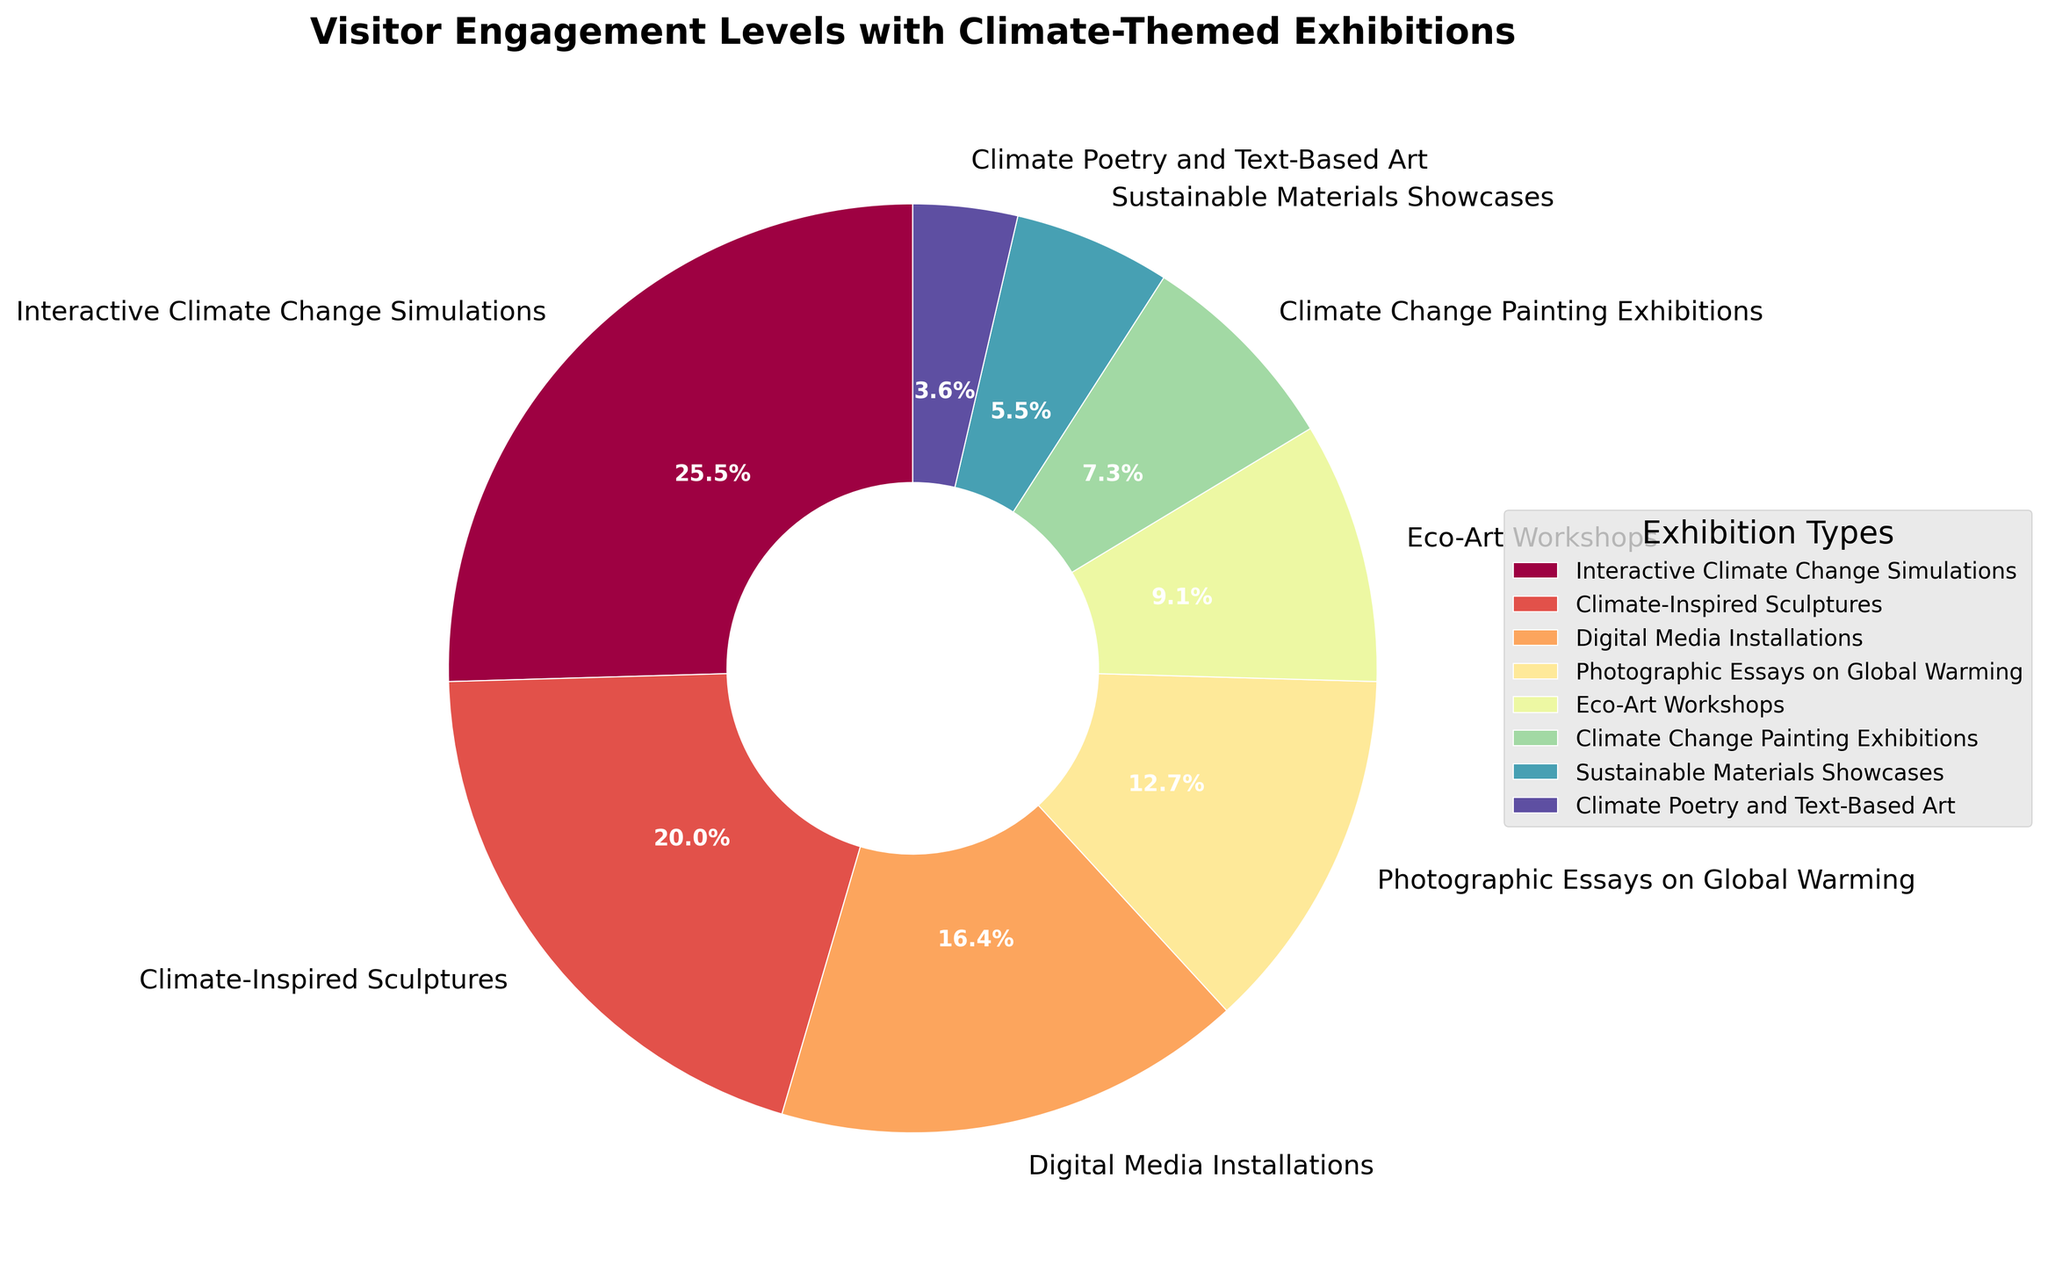Which climate-themed exhibition category has the highest visitor engagement? The figure shows "Interactive Climate Change Simulations" with the largest wedge in the pie chart, labeled 28%. This indicates it has the highest visitor engagement.
Answer: Interactive Climate Change Simulations How many percentage points greater is the engagement with Climate-Inspired Sculptures compared to Climate Change Painting Exhibitions? Climate-Inspired Sculptures engage 22% of visitors while Climate Change Painting Exhibitions engage 8%. The difference is calculated by subtracting 8% from 22%.
Answer: 14% Rank the exhibitions from highest to lowest engagement level. Sorting the categories by the percentage values from the pie chart: Interactive Climate Change Simulations (28%), Climate-Inspired Sculptures (22%), Digital Media Installations (18%), Photographic Essays on Global Warming (14%), Eco-Art Workshops (10%), Climate Change Painting Exhibitions (8%), Sustainable Materials Showcases (6%), Climate Poetry and Text-Based Art (4%).
Answer: Interactive Climate Change Simulations, Climate-Inspired Sculptures, Digital Media Installations, Photographic Essays on Global Warming, Eco-Art Workshops, Climate Change Painting Exhibitions, Sustainable Materials Showcases, Climate Poetry and Text-Based Art Are there more people engaged with Digital Media Installations or Eco-Art Workshops? According to the pie chart, Digital Media Installations engage 18% of visitors, whereas Eco-Art Workshops engage 10%. 18% is greater than 10%.
Answer: Digital Media Installations What is the combined engagement percentage for categories engaging less than 10% individually? The categories with less than 10% engagement are Climate Change Painting Exhibitions (8%), Sustainable Materials Showcases (6%), and Climate Poetry and Text-Based Art (4%). Summing these percentages: 8% + 6% + 4% = 18%.
Answer: 18% Which exhibition category has the smallest visitor engagement? The smallest wedge on the pie chart is labeled "Climate Poetry and Text-Based Art" with 4% engagement.
Answer: Climate Poetry and Text-Based Art How does the engagement with Photographic Essays on Global Warming compare to Sustainable Materials Showcases? Photographic Essays on Global Warming engage 14% of visitors, while Sustainable Materials Showcases engage 6%. 14% is more than 6%.
Answer: Photographic Essays on Global Warming What is the difference in engagement between the highest and lowest categories? The highest engagement is 28% (Interactive Climate Change Simulations) and the lowest is 4% (Climate Poetry and Text-Based Art). The difference is 28% - 4%.
Answer: 24% If you combine the engagement percentages of Climate-Inspired Sculptures and Photographic Essays on Global Warming, what is the total? The engagement for Climate-Inspired Sculptures is 22% and Photographic Essays on Global Warming is 14%. Adding these: 22% + 14% = 36%.
Answer: 36% What percentage of visitors engage with exhibitions other than Interactive Climate Change Simulations? Interactive Climate Change Simulations engage 28% of visitors. To find the percentage for other exhibitions, subtract this from 100%: 100% - 28% = 72%.
Answer: 72% 